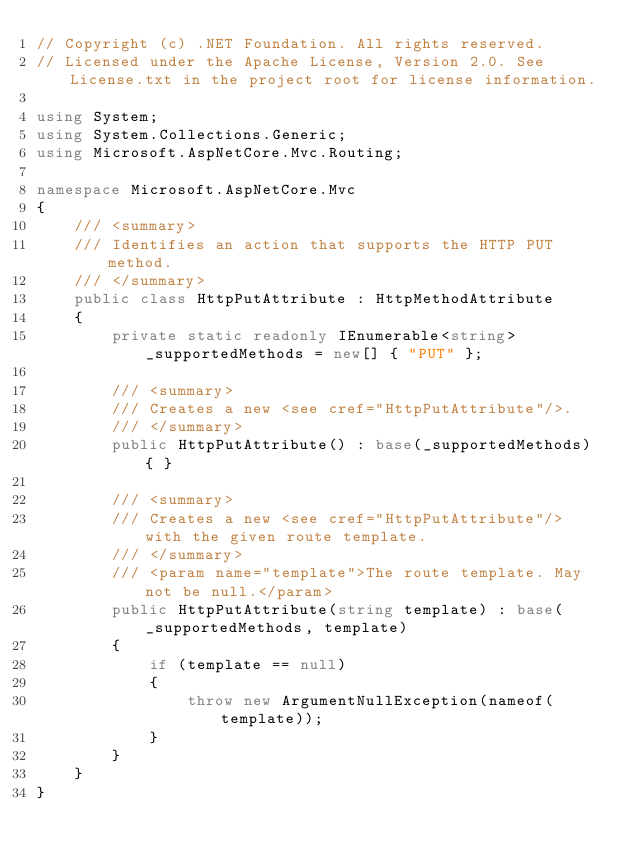<code> <loc_0><loc_0><loc_500><loc_500><_C#_>// Copyright (c) .NET Foundation. All rights reserved.
// Licensed under the Apache License, Version 2.0. See License.txt in the project root for license information.

using System;
using System.Collections.Generic;
using Microsoft.AspNetCore.Mvc.Routing;

namespace Microsoft.AspNetCore.Mvc
{
    /// <summary>
    /// Identifies an action that supports the HTTP PUT method.
    /// </summary>
    public class HttpPutAttribute : HttpMethodAttribute
    {
        private static readonly IEnumerable<string> _supportedMethods = new[] { "PUT" };

        /// <summary>
        /// Creates a new <see cref="HttpPutAttribute"/>.
        /// </summary>
        public HttpPutAttribute() : base(_supportedMethods) { }

        /// <summary>
        /// Creates a new <see cref="HttpPutAttribute"/> with the given route template.
        /// </summary>
        /// <param name="template">The route template. May not be null.</param>
        public HttpPutAttribute(string template) : base(_supportedMethods, template)
        {
            if (template == null)
            {
                throw new ArgumentNullException(nameof(template));
            }
        }
    }
}
</code> 